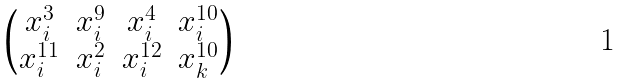<formula> <loc_0><loc_0><loc_500><loc_500>\begin{pmatrix} x _ { i } ^ { 3 } & x _ { i } ^ { 9 } & x _ { i } ^ { 4 } & x _ { i } ^ { 1 0 } \\ x _ { i } ^ { 1 1 } & x _ { i } ^ { 2 } & x _ { i } ^ { 1 2 } & x _ { k } ^ { 1 0 } \end{pmatrix}</formula> 